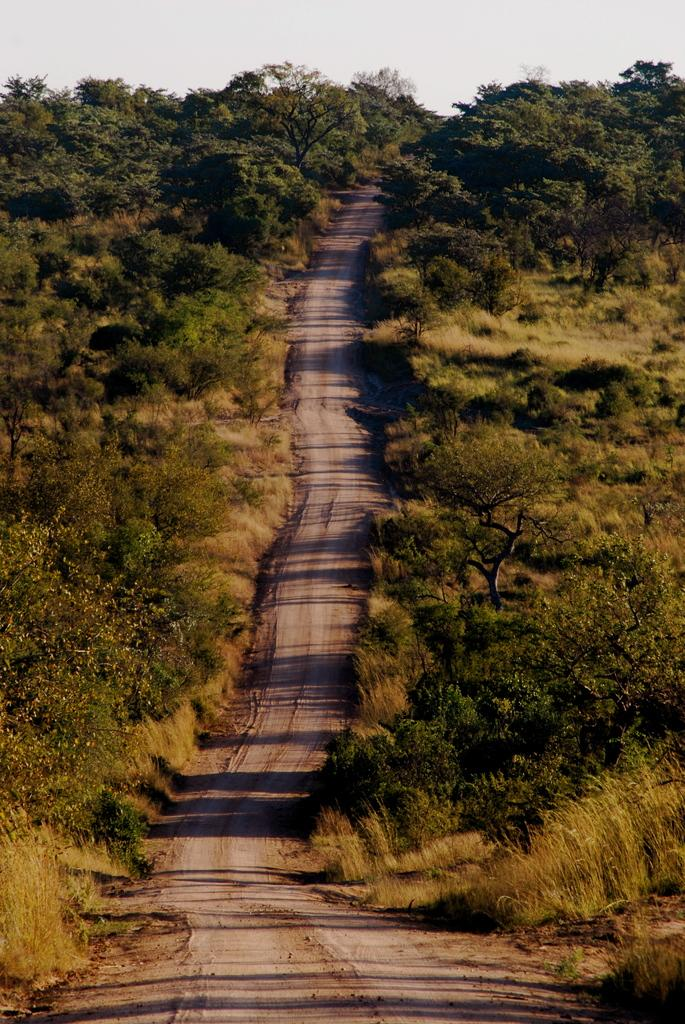What is the main feature in the middle of the image? There is a road in the middle of the image. What can be seen on both sides of the road? There are trees and plants on both sides of the road. What is visible in the background of the image? The sky is visible in the background of the image. What type of sound can be heard coming from the picture in the image? There is no sound present in the image, as it is a still photograph. What belief is depicted in the image? The image does not depict any specific belief; it is a scene of a road with trees and plants on both sides. 